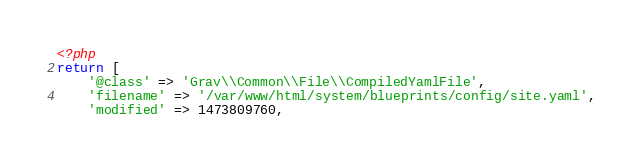Convert code to text. <code><loc_0><loc_0><loc_500><loc_500><_PHP_><?php
return [
    '@class' => 'Grav\\Common\\File\\CompiledYamlFile',
    'filename' => '/var/www/html/system/blueprints/config/site.yaml',
    'modified' => 1473809760,</code> 